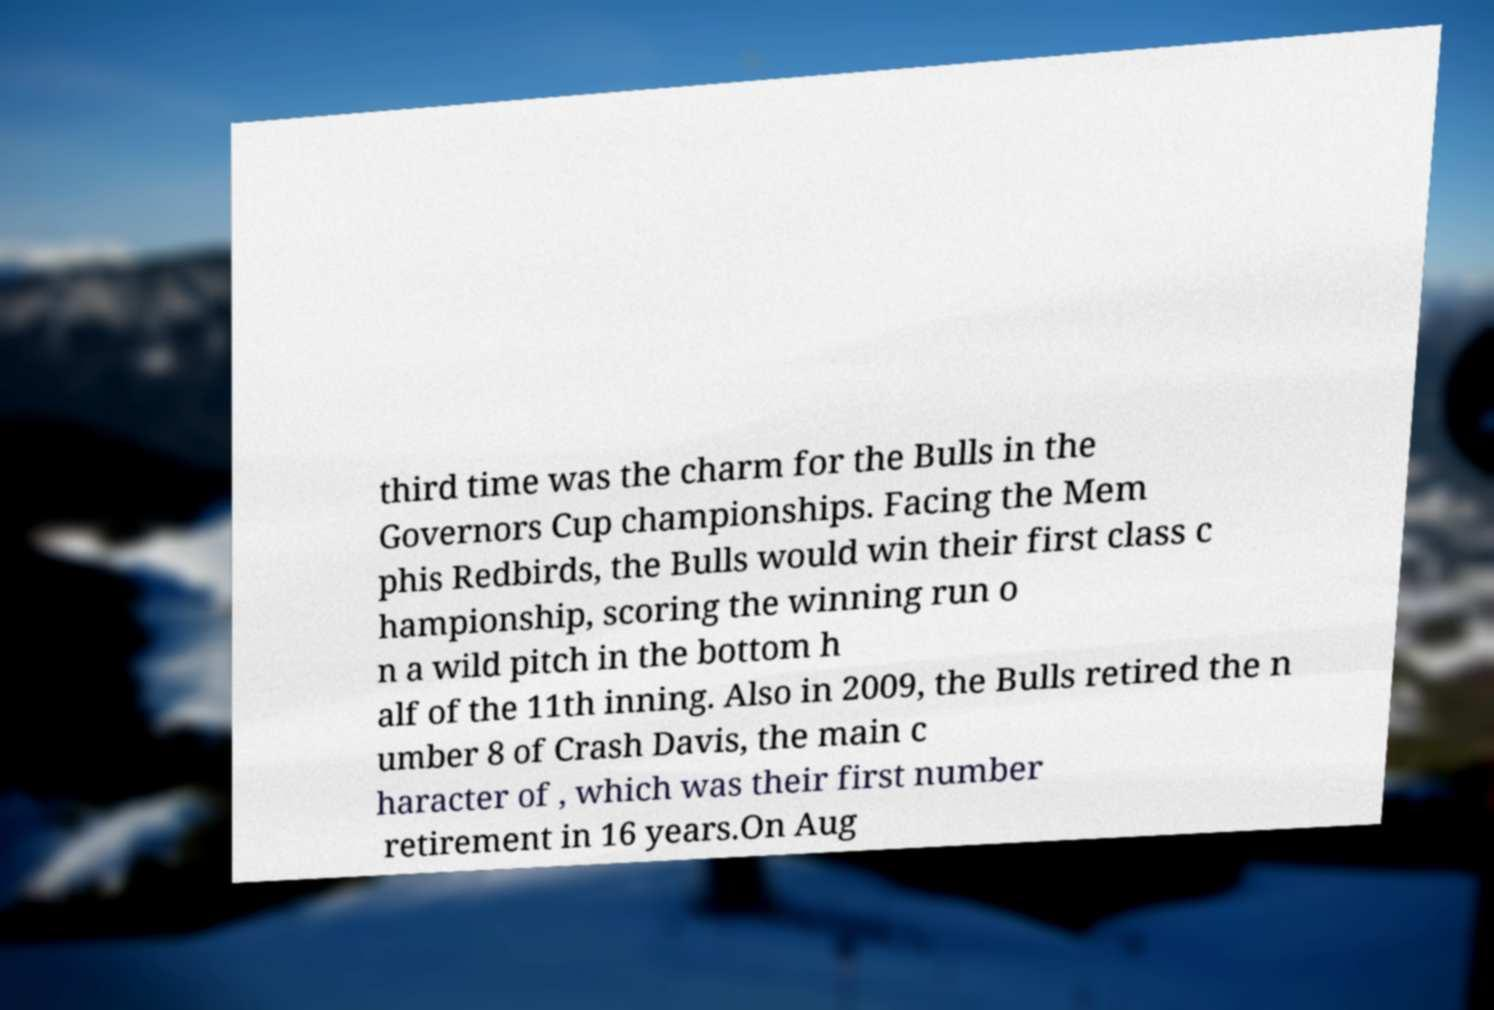Can you read and provide the text displayed in the image?This photo seems to have some interesting text. Can you extract and type it out for me? third time was the charm for the Bulls in the Governors Cup championships. Facing the Mem phis Redbirds, the Bulls would win their first class c hampionship, scoring the winning run o n a wild pitch in the bottom h alf of the 11th inning. Also in 2009, the Bulls retired the n umber 8 of Crash Davis, the main c haracter of , which was their first number retirement in 16 years.On Aug 